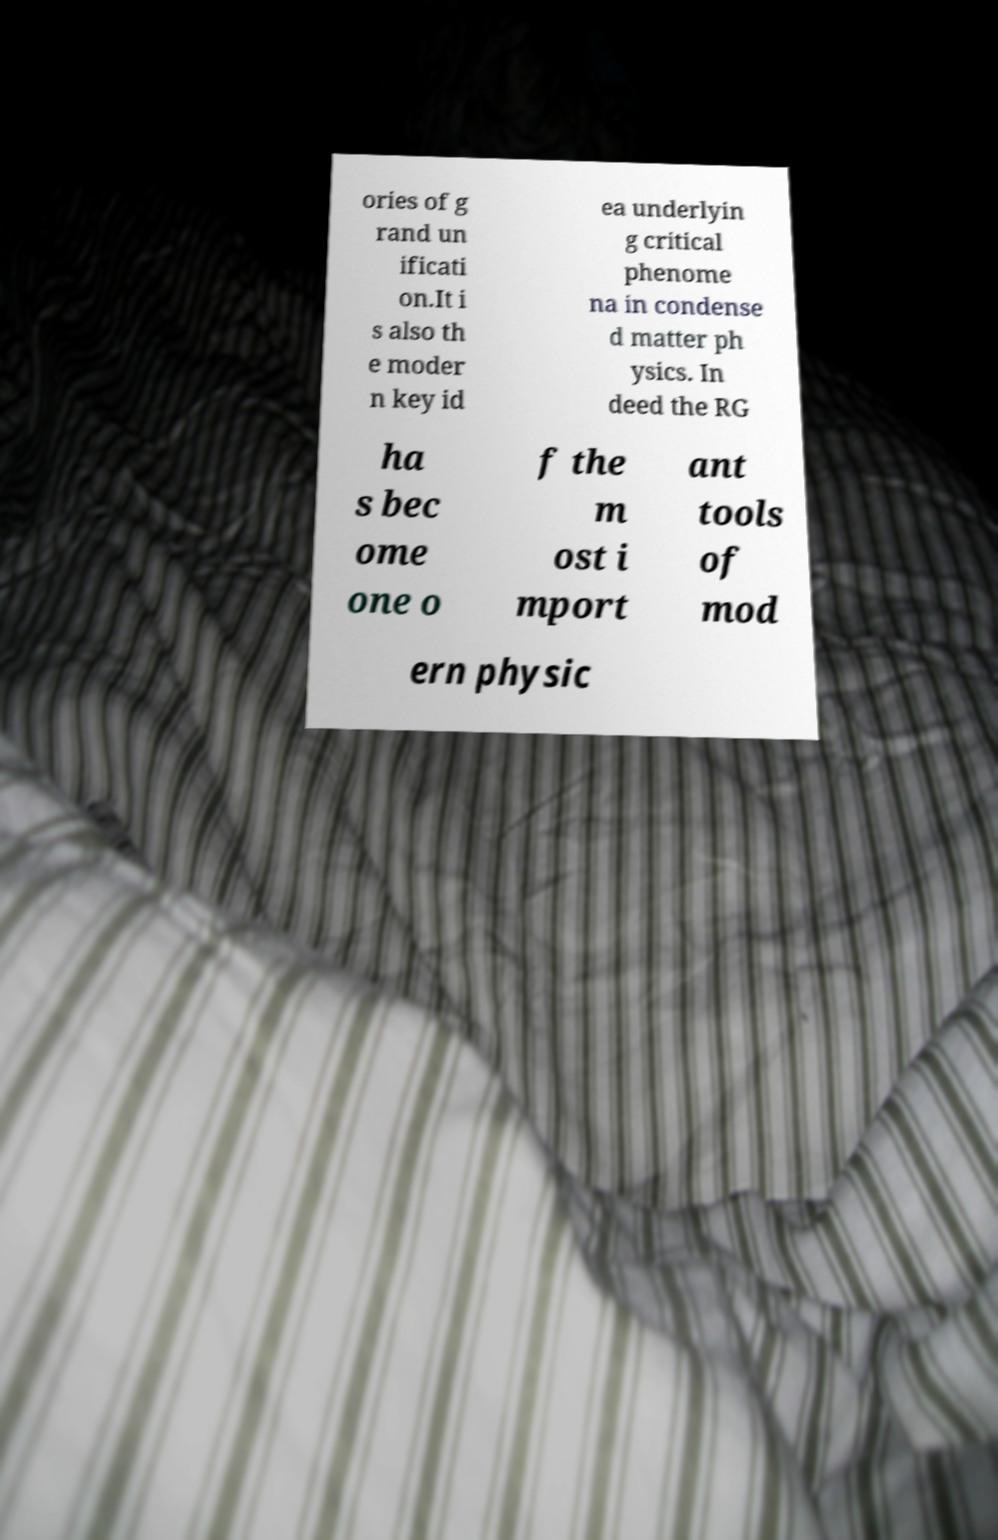Please identify and transcribe the text found in this image. ories of g rand un ificati on.It i s also th e moder n key id ea underlyin g critical phenome na in condense d matter ph ysics. In deed the RG ha s bec ome one o f the m ost i mport ant tools of mod ern physic 